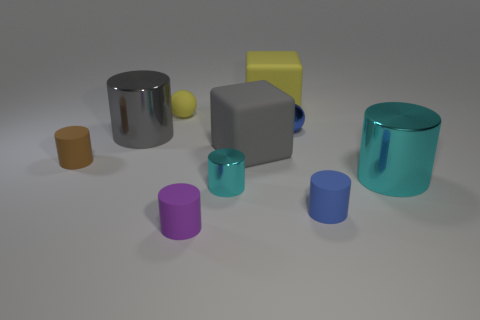Subtract all purple cylinders. How many cylinders are left? 5 Subtract all blue spheres. How many spheres are left? 1 Subtract 2 spheres. How many spheres are left? 0 Subtract all cylinders. How many objects are left? 4 Subtract all brown spheres. How many cyan cylinders are left? 2 Subtract all big metallic things. Subtract all small purple rubber cylinders. How many objects are left? 7 Add 8 brown rubber cylinders. How many brown rubber cylinders are left? 9 Add 7 small cyan objects. How many small cyan objects exist? 8 Subtract 0 red cylinders. How many objects are left? 10 Subtract all yellow cylinders. Subtract all green balls. How many cylinders are left? 6 